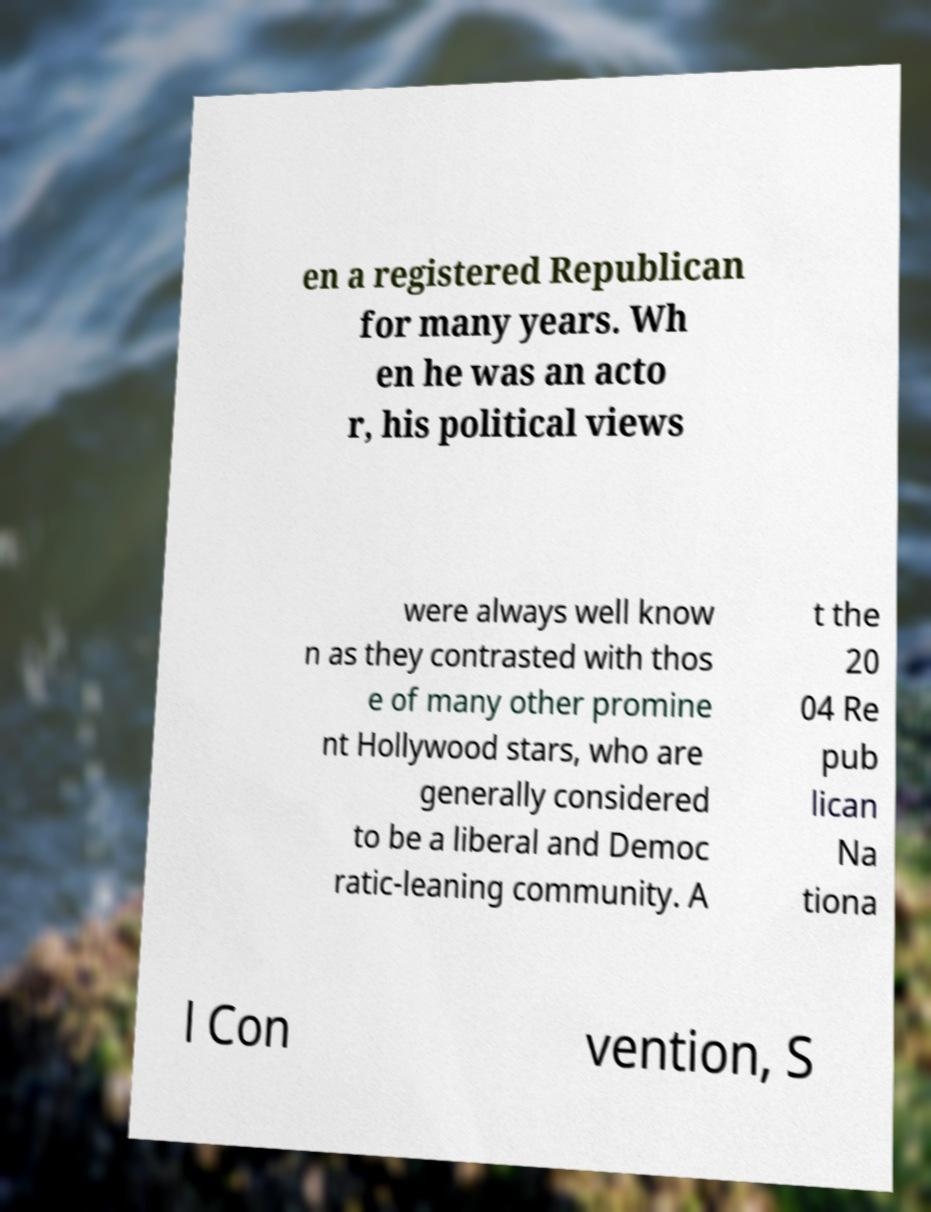Could you extract and type out the text from this image? en a registered Republican for many years. Wh en he was an acto r, his political views were always well know n as they contrasted with thos e of many other promine nt Hollywood stars, who are generally considered to be a liberal and Democ ratic-leaning community. A t the 20 04 Re pub lican Na tiona l Con vention, S 